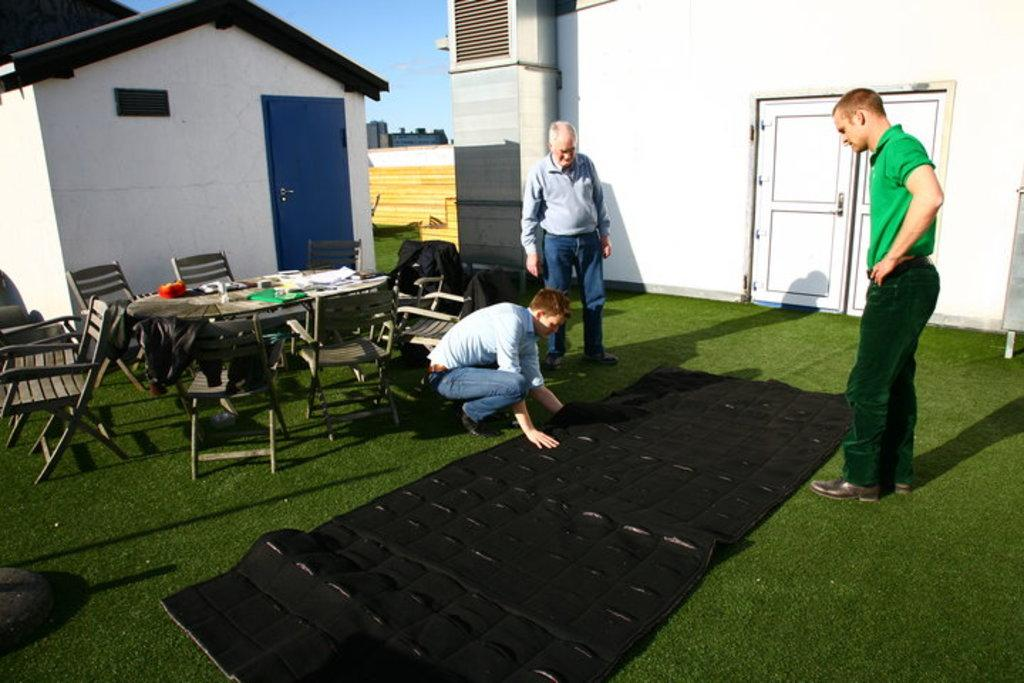How many houses are visible in the image? There are two houses in the image. What else can be seen in the image besides the houses? There are three men, green grass, a table, and chairs in the image. What might the men be using the table for? The men might be using the table for sitting, eating, or working, as there are chairs present in the image as well. What type of beast can be seen whipping the grass in the image? There is no beast present in the image, nor is there any whipping of the grass. 